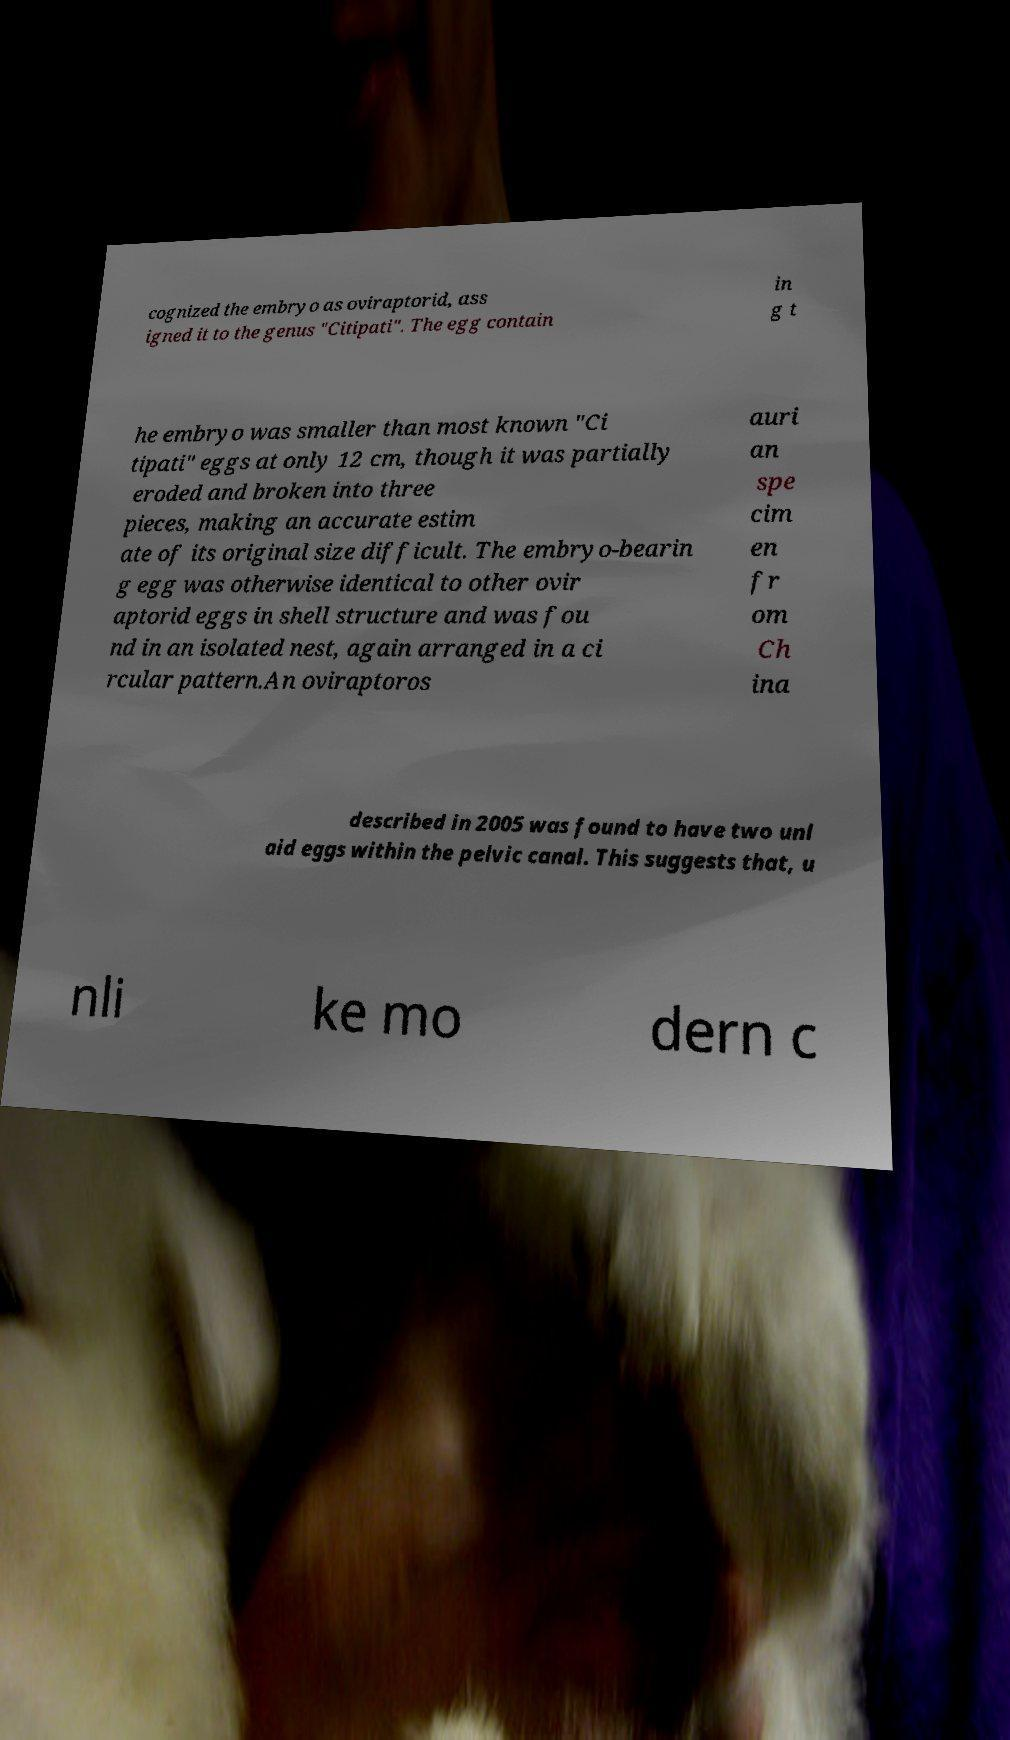Could you extract and type out the text from this image? cognized the embryo as oviraptorid, ass igned it to the genus "Citipati". The egg contain in g t he embryo was smaller than most known "Ci tipati" eggs at only 12 cm, though it was partially eroded and broken into three pieces, making an accurate estim ate of its original size difficult. The embryo-bearin g egg was otherwise identical to other ovir aptorid eggs in shell structure and was fou nd in an isolated nest, again arranged in a ci rcular pattern.An oviraptoros auri an spe cim en fr om Ch ina described in 2005 was found to have two unl aid eggs within the pelvic canal. This suggests that, u nli ke mo dern c 